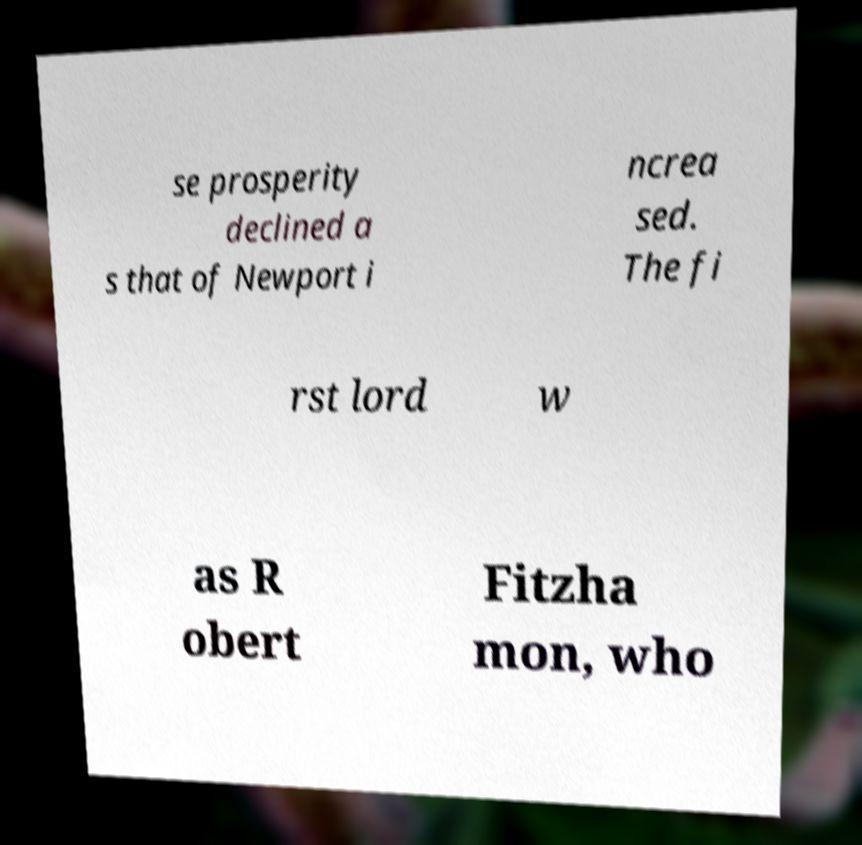For documentation purposes, I need the text within this image transcribed. Could you provide that? se prosperity declined a s that of Newport i ncrea sed. The fi rst lord w as R obert Fitzha mon, who 